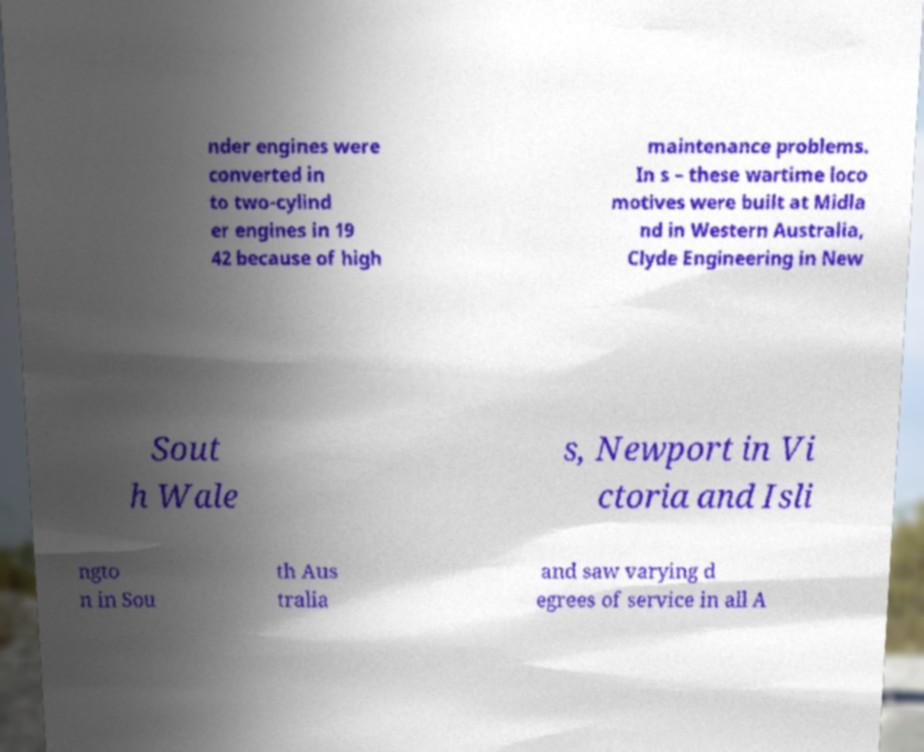There's text embedded in this image that I need extracted. Can you transcribe it verbatim? nder engines were converted in to two-cylind er engines in 19 42 because of high maintenance problems. In s – these wartime loco motives were built at Midla nd in Western Australia, Clyde Engineering in New Sout h Wale s, Newport in Vi ctoria and Isli ngto n in Sou th Aus tralia and saw varying d egrees of service in all A 